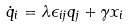Convert formula to latex. <formula><loc_0><loc_0><loc_500><loc_500>\dot { q } _ { i } = \lambda \epsilon _ { i j } q _ { j } + \gamma x _ { i }</formula> 